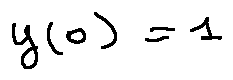Convert formula to latex. <formula><loc_0><loc_0><loc_500><loc_500>y ( 0 ) = 1</formula> 